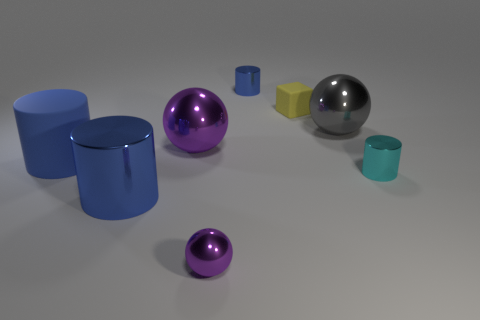Is there any other thing that is the same shape as the yellow matte object?
Your answer should be compact. No. There is a matte object that is in front of the yellow object; what number of blue shiny things are left of it?
Offer a terse response. 0. What number of objects are either big green metallic balls or small yellow rubber blocks?
Your answer should be compact. 1. Do the tiny purple metallic thing and the gray shiny object have the same shape?
Give a very brief answer. Yes. What is the material of the tiny yellow block?
Your answer should be very brief. Rubber. What number of blue cylinders are both in front of the large purple shiny ball and right of the large shiny cylinder?
Your response must be concise. 0. Is the yellow rubber block the same size as the gray thing?
Provide a succinct answer. No. There is a blue metal cylinder behind the gray shiny sphere; is its size the same as the small yellow matte block?
Your answer should be very brief. Yes. What color is the object that is on the right side of the big gray object?
Your answer should be very brief. Cyan. How many tiny gray things are there?
Provide a short and direct response. 0. 